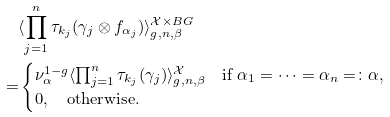<formula> <loc_0><loc_0><loc_500><loc_500>& \langle \prod _ { j = 1 } ^ { n } \tau _ { k _ { j } } ( \gamma _ { j } \otimes f _ { \alpha _ { j } } ) \rangle _ { g , n , \beta } ^ { \mathcal { X } \times B G } \\ = & \begin{cases} \nu _ { \alpha } ^ { 1 - g } \langle \prod _ { j = 1 } ^ { n } \tau _ { k _ { j } } ( \gamma _ { j } ) \rangle _ { g , n , \beta } ^ { \mathcal { X } } \quad \text {if } \alpha _ { 1 } = \dots = \alpha _ { n } = \colon \alpha , \\ 0 , \quad \text {otherwise} . \end{cases}</formula> 